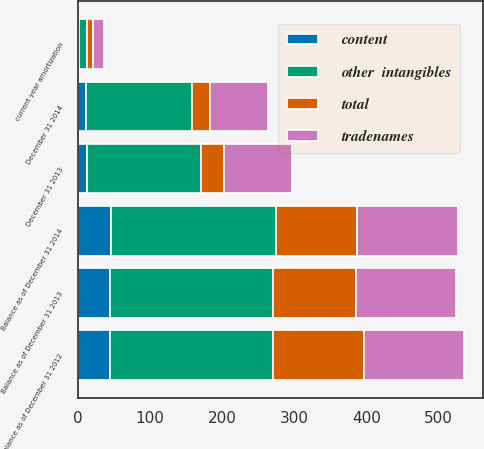Convert chart to OTSL. <chart><loc_0><loc_0><loc_500><loc_500><stacked_bar_chart><ecel><fcel>Balance as of December 31 2012<fcel>Balance as of December 31 2013<fcel>Balance as of December 31 2014<fcel>current year amortization<fcel>December 31 2013<fcel>December 31 2014<nl><fcel>total<fcel>126<fcel>115<fcel>113<fcel>9<fcel>32<fcel>25<nl><fcel>tradenames<fcel>139<fcel>139<fcel>139<fcel>14<fcel>94<fcel>80<nl><fcel>other  intangibles<fcel>225<fcel>225<fcel>228<fcel>11<fcel>158<fcel>148<nl><fcel>content<fcel>45<fcel>45<fcel>46<fcel>2<fcel>13<fcel>11<nl></chart> 